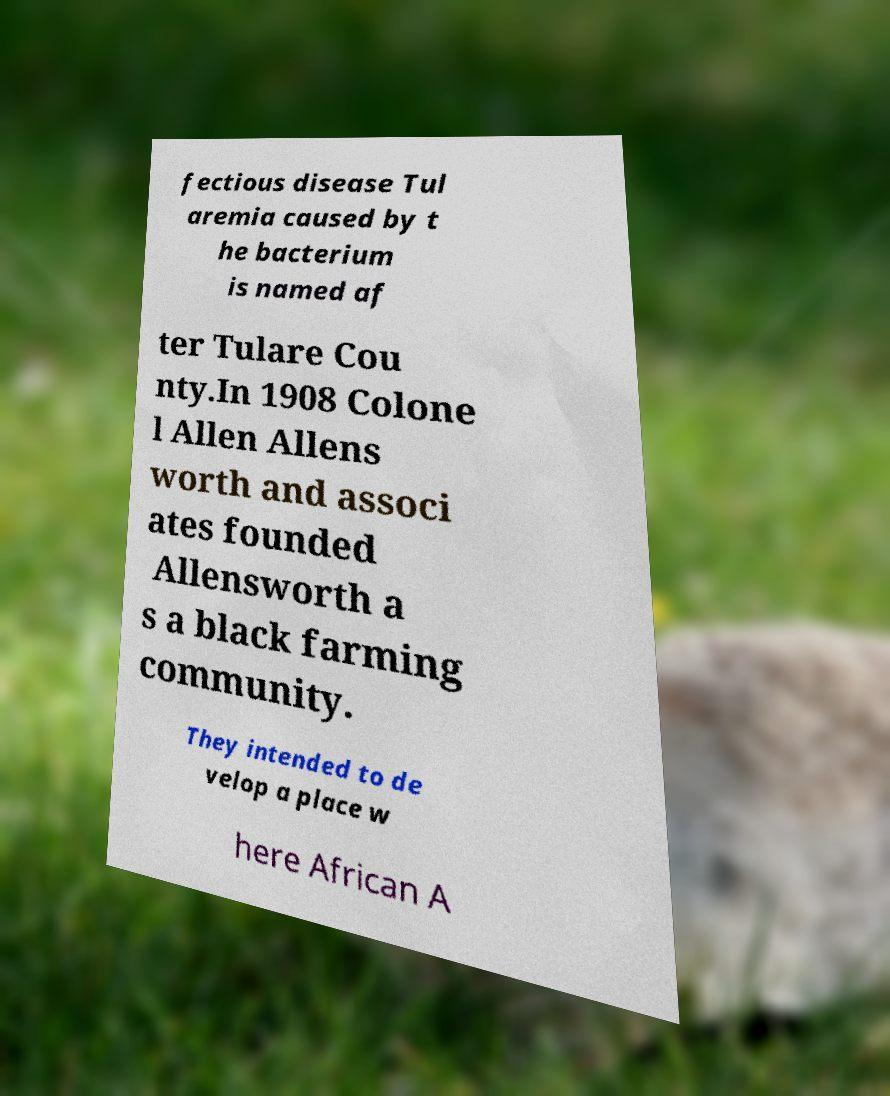There's text embedded in this image that I need extracted. Can you transcribe it verbatim? fectious disease Tul aremia caused by t he bacterium is named af ter Tulare Cou nty.In 1908 Colone l Allen Allens worth and associ ates founded Allensworth a s a black farming community. They intended to de velop a place w here African A 